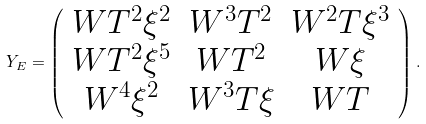Convert formula to latex. <formula><loc_0><loc_0><loc_500><loc_500>Y _ { E } = \left ( \begin{array} { c c c } { { W T ^ { 2 } \xi ^ { 2 } } } & { { W ^ { 3 } T ^ { 2 } } } & { { W ^ { 2 } T \xi ^ { 3 } } } \\ { { W T ^ { 2 } \xi ^ { 5 } } } & { { W T ^ { 2 } } } & { W \xi } \\ { { W ^ { 4 } \xi ^ { 2 } } } & { { W ^ { 3 } T \xi } } & { W T } \end{array} \right ) .</formula> 